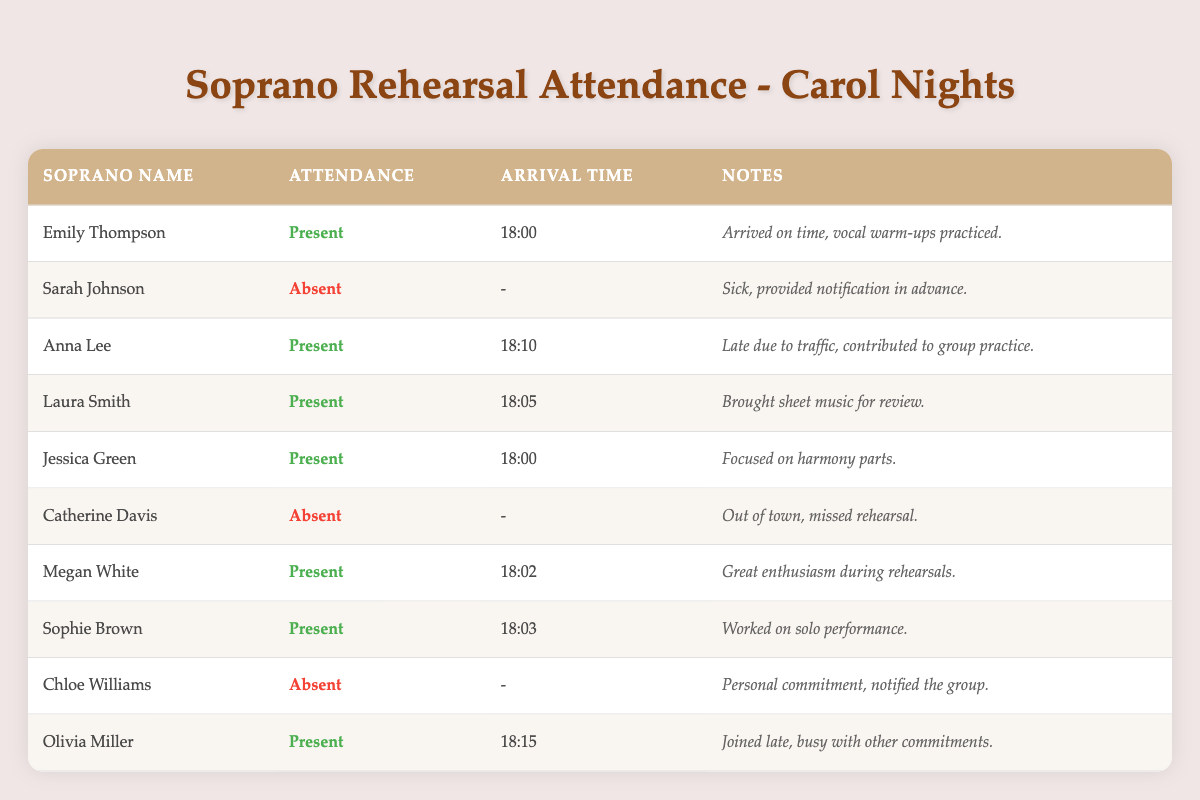What is the attendance status of Laura Smith? According to the table, Laura Smith is marked as present on the rehearsal date, which means she attended the rehearsal.
Answer: Present How many sopranos attended the rehearsal on November 1st, 2023? By counting the entries with "Attendance" marked as true in the table, we find that there are 6 sopranos who attended the rehearsal: Emily Thompson, Anna Lee, Laura Smith, Jessica Green, Megan White, Sophie Brown, and Olivia Miller.
Answer: 6 Which soprano arrived the latest to the rehearsal? To determine who arrived the latest, I compare the arrival times. Olivia Miller arrived at 18:15, which is the latest time recorded among all sopranos present.
Answer: Olivia Miller Did any sopranos notify the group of their absence in advance? Looking at the "Notes" column for the sopranos marked as absent, both Sarah Johnson and Chloe Williams provided notifications for their absence. Thus, the answer is yes.
Answer: Yes What was the average arrival time for the sopranos who attended the rehearsal? The arrival times for those who attended are 18:00, 18:10, 18:05, 18:00, 18:02, 18:03, and 18:15. Converting these to minutes (18:00=1080, 18:10=1090, 18:05=1085, 18:00=1080, 18:02=1082, 18:03=1083, and 18:15=1095), we sum these values (1080 + 1090 + 1085 + 1080 + 1082 + 1083 + 1095 = 7625) and divide by the number of attendees (6). The average time in minutes is 7625 / 6 = approximately 1270.83 minutes; converting back to hours gives approximately 18:05 (18:05).
Answer: 18:05 How many sopranos were absent due to personal commitments? Chloe Williams is the only soprano noted as absent due to personal commitments, as per her notes in the table.
Answer: 1 Which soprano was late to the rehearsal and what reason was provided? Anna Lee arrived at 18:10, which is late compared to the others, noting her reason as late due to traffic.
Answer: Anna Lee, due to traffic What can be inferred about the enthusiasm of Megan White during rehearsals? The notes for Megan White state "Great enthusiasm during rehearsals," indicating a positive and eager approach towards her participation.
Answer: Great enthusiasm 